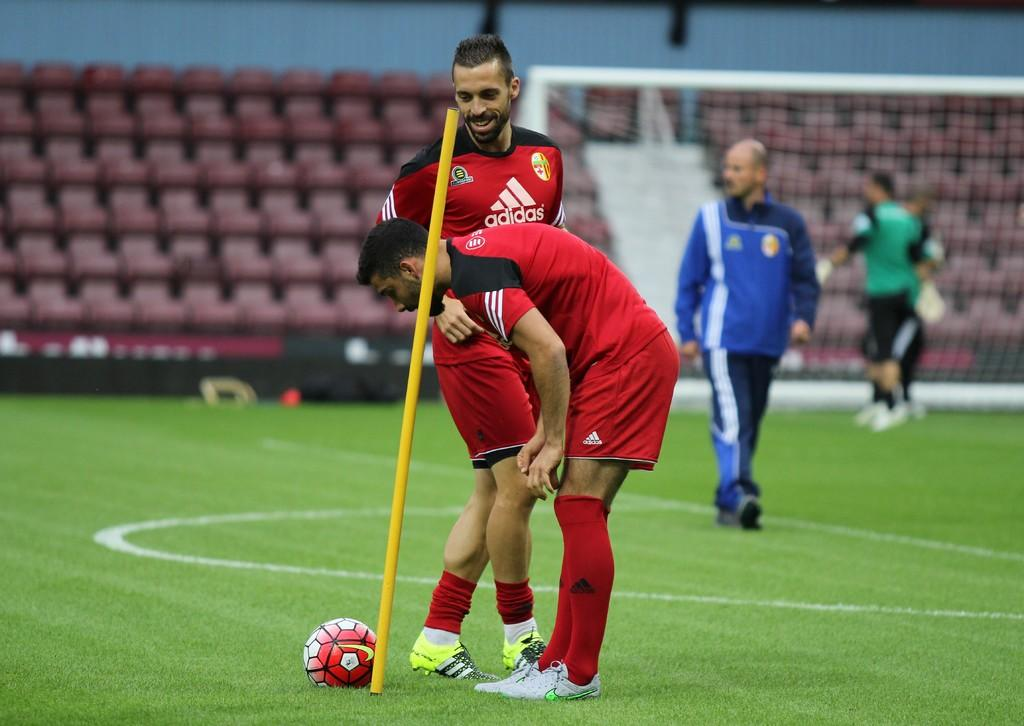<image>
Offer a succinct explanation of the picture presented. A player in an Adidas shirt smiles and looks at his teammate and the ball. 